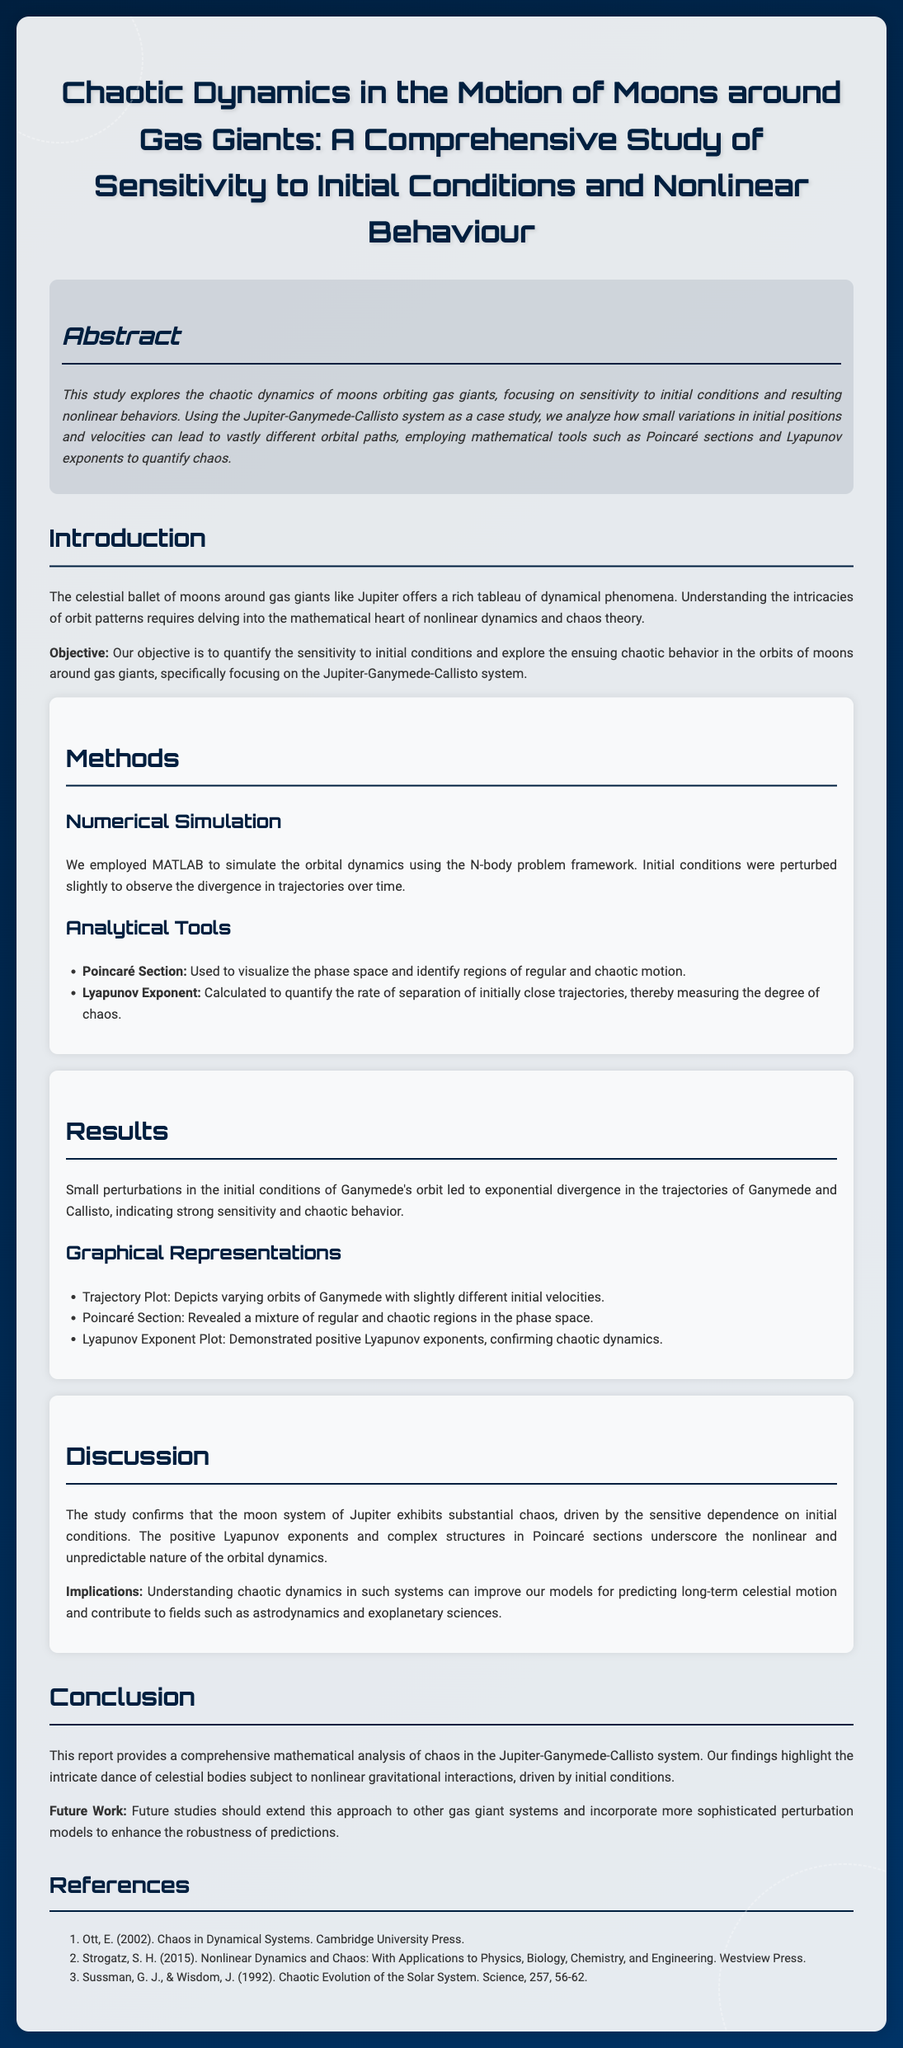What is the primary focus of the study? The study primarily explores the chaotic dynamics of moons orbiting gas giants, specifically sensitivity to initial conditions and nonlinear behaviors.
Answer: Chaotic dynamics What system is used as a case study in the research? The research specifically analyzes the Jupiter-Ganymede-Callisto system as a case study.
Answer: Jupiter-Ganymede-Callisto system What is the method used for the quantitative analysis of chaos? The method used to quantify chaos is the calculation of the Lyapunov exponent which measures the degree of chaos.
Answer: Lyapunov exponent What type of plot is used to visualize the phase space in the study? A Poincaré section is utilized to visualize the phase space and identify regions of regular and chaotic motion.
Answer: Poincaré section What are small perturbations in initial conditions shown to cause in Ganymede's orbit? Small perturbations in initial conditions lead to exponential divergence in the trajectories of Ganymede and Callisto, indicating chaos.
Answer: Exponential divergence What do positive Lyapunov exponents indicate in the results? Positive Lyapunov exponents confirm the chaotic dynamics present in the orbits studied.
Answer: Chaotic dynamics What implication does the study suggest regarding future modeling of celestial motion? The study suggests that understanding chaotic dynamics can improve models for predicting long-term celestial motion.
Answer: Improved models What is recommended for future studies in this area? Future studies should extend the approach to other gas giant systems and incorporate sophisticated perturbation models.
Answer: Extend to other gas giant systems 